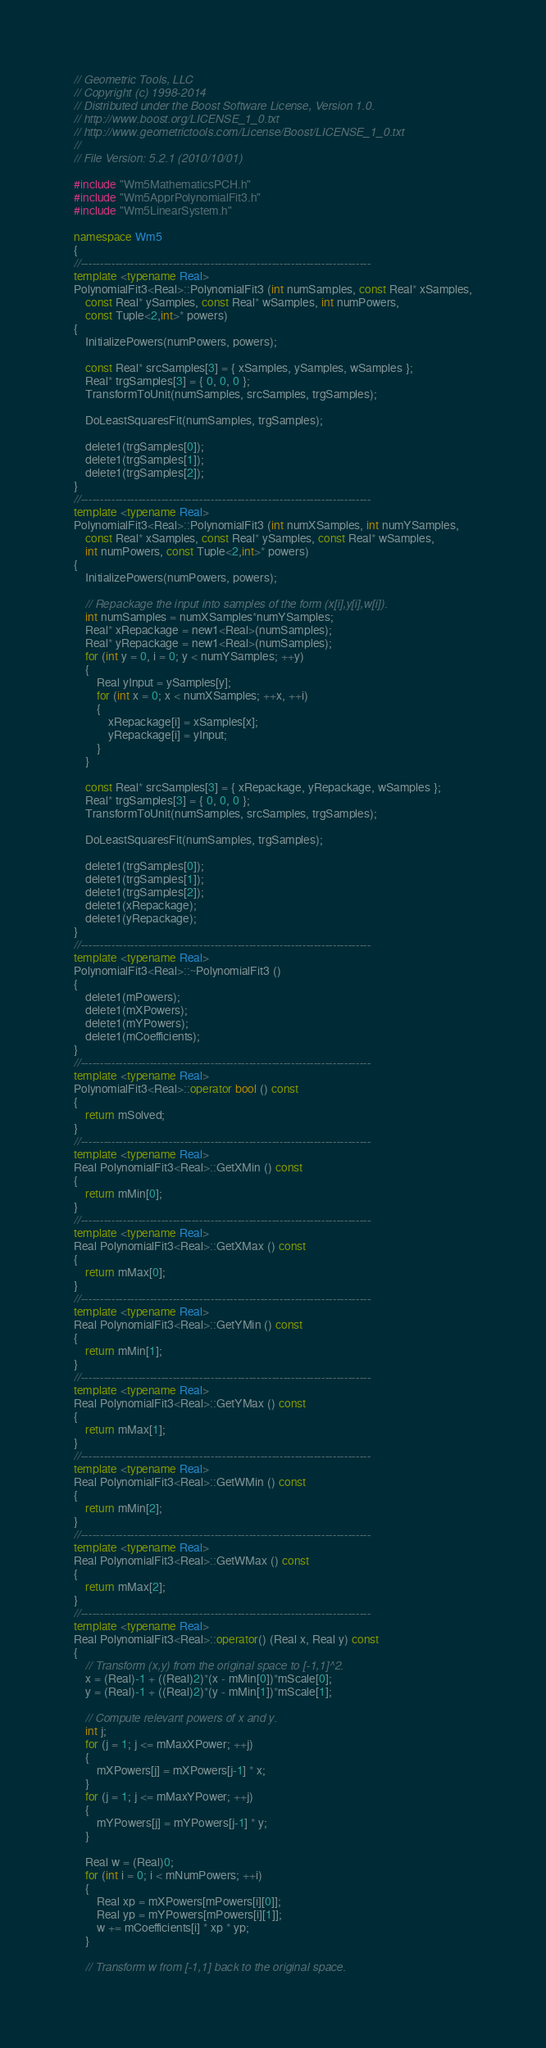Convert code to text. <code><loc_0><loc_0><loc_500><loc_500><_C++_>// Geometric Tools, LLC
// Copyright (c) 1998-2014
// Distributed under the Boost Software License, Version 1.0.
// http://www.boost.org/LICENSE_1_0.txt
// http://www.geometrictools.com/License/Boost/LICENSE_1_0.txt
//
// File Version: 5.2.1 (2010/10/01)

#include "Wm5MathematicsPCH.h"
#include "Wm5ApprPolynomialFit3.h"
#include "Wm5LinearSystem.h"

namespace Wm5
{
//----------------------------------------------------------------------------
template <typename Real>
PolynomialFit3<Real>::PolynomialFit3 (int numSamples, const Real* xSamples,
    const Real* ySamples, const Real* wSamples, int numPowers,
    const Tuple<2,int>* powers)
{
    InitializePowers(numPowers, powers);

    const Real* srcSamples[3] = { xSamples, ySamples, wSamples };
    Real* trgSamples[3] = { 0, 0, 0 };
    TransformToUnit(numSamples, srcSamples, trgSamples);

    DoLeastSquaresFit(numSamples, trgSamples);

    delete1(trgSamples[0]);
    delete1(trgSamples[1]);
    delete1(trgSamples[2]);
}
//----------------------------------------------------------------------------
template <typename Real>
PolynomialFit3<Real>::PolynomialFit3 (int numXSamples, int numYSamples,
    const Real* xSamples, const Real* ySamples, const Real* wSamples,
    int numPowers, const Tuple<2,int>* powers)
{
    InitializePowers(numPowers, powers);

    // Repackage the input into samples of the form (x[i],y[i],w[i]).
    int numSamples = numXSamples*numYSamples;
    Real* xRepackage = new1<Real>(numSamples);
    Real* yRepackage = new1<Real>(numSamples);
    for (int y = 0, i = 0; y < numYSamples; ++y)
    {
        Real yInput = ySamples[y];
        for (int x = 0; x < numXSamples; ++x, ++i)
        {
            xRepackage[i] = xSamples[x];
            yRepackage[i] = yInput;
        }
    }

    const Real* srcSamples[3] = { xRepackage, yRepackage, wSamples };
    Real* trgSamples[3] = { 0, 0, 0 };
    TransformToUnit(numSamples, srcSamples, trgSamples);

    DoLeastSquaresFit(numSamples, trgSamples);

    delete1(trgSamples[0]);
    delete1(trgSamples[1]);
    delete1(trgSamples[2]);
    delete1(xRepackage);
    delete1(yRepackage);
}
//----------------------------------------------------------------------------
template <typename Real>
PolynomialFit3<Real>::~PolynomialFit3 ()
{
    delete1(mPowers);
    delete1(mXPowers);
    delete1(mYPowers);
    delete1(mCoefficients);
}
//----------------------------------------------------------------------------
template <typename Real>
PolynomialFit3<Real>::operator bool () const
{
    return mSolved;
}
//----------------------------------------------------------------------------
template <typename Real>
Real PolynomialFit3<Real>::GetXMin () const
{
    return mMin[0];
}
//----------------------------------------------------------------------------
template <typename Real>
Real PolynomialFit3<Real>::GetXMax () const
{
    return mMax[0];
}
//----------------------------------------------------------------------------
template <typename Real>
Real PolynomialFit3<Real>::GetYMin () const
{
    return mMin[1];
}
//----------------------------------------------------------------------------
template <typename Real>
Real PolynomialFit3<Real>::GetYMax () const
{
    return mMax[1];
}
//----------------------------------------------------------------------------
template <typename Real>
Real PolynomialFit3<Real>::GetWMin () const
{
    return mMin[2];
}
//----------------------------------------------------------------------------
template <typename Real>
Real PolynomialFit3<Real>::GetWMax () const
{
    return mMax[2];
}
//----------------------------------------------------------------------------
template <typename Real>
Real PolynomialFit3<Real>::operator() (Real x, Real y) const
{
    // Transform (x,y) from the original space to [-1,1]^2.
    x = (Real)-1 + ((Real)2)*(x - mMin[0])*mScale[0];
    y = (Real)-1 + ((Real)2)*(y - mMin[1])*mScale[1];

    // Compute relevant powers of x and y.
    int j;
    for (j = 1; j <= mMaxXPower; ++j)
    {
        mXPowers[j] = mXPowers[j-1] * x;
    }
    for (j = 1; j <= mMaxYPower; ++j)
    {
        mYPowers[j] = mYPowers[j-1] * y;
    }

    Real w = (Real)0;
    for (int i = 0; i < mNumPowers; ++i)
    {
        Real xp = mXPowers[mPowers[i][0]];
        Real yp = mYPowers[mPowers[i][1]];
        w += mCoefficients[i] * xp * yp;
    }

    // Transform w from [-1,1] back to the original space.</code> 